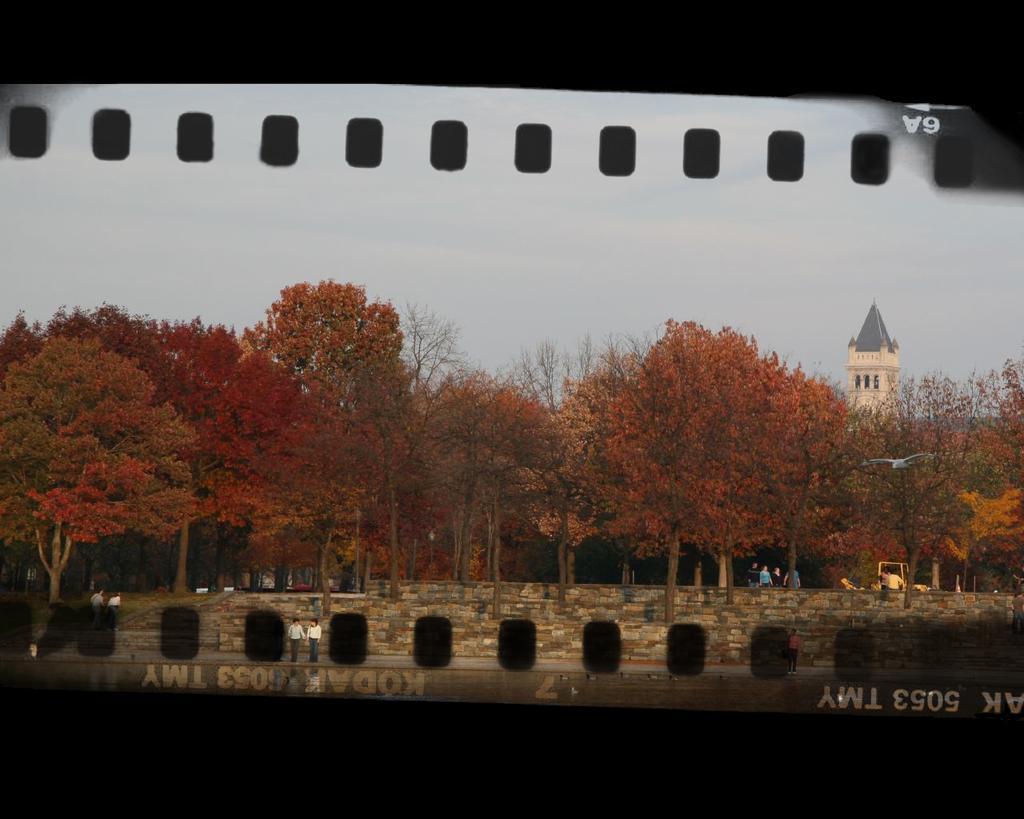Can you describe this image briefly? This picture seems to be an edited image. In the center there are two persons seems to be standing on the ground and we can see the group of people and we can see the trees, stairs. In the background there is a sky and a spire. At the bottom we can see the text on the image. 